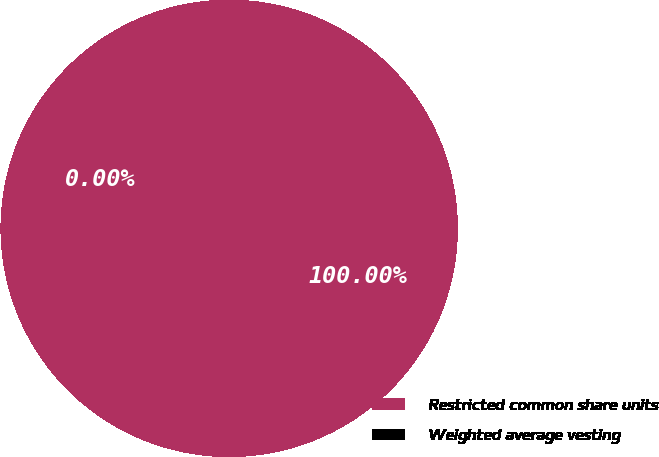Convert chart. <chart><loc_0><loc_0><loc_500><loc_500><pie_chart><fcel>Restricted common share units<fcel>Weighted average vesting<nl><fcel>100.0%<fcel>0.0%<nl></chart> 